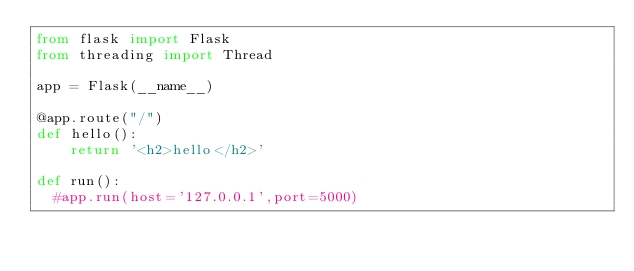Convert code to text. <code><loc_0><loc_0><loc_500><loc_500><_Python_>from flask import Flask
from threading import Thread

app = Flask(__name__)

@app.route("/")
def hello():
    return '<h2>hello</h2>'

def run():
  #app.run(host='127.0.0.1',port=5000)</code> 